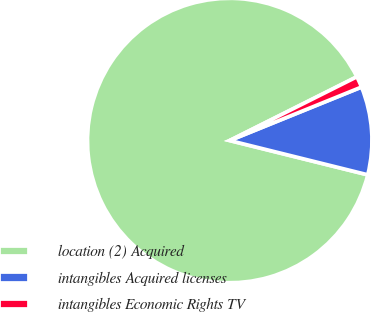Convert chart. <chart><loc_0><loc_0><loc_500><loc_500><pie_chart><fcel>location (2) Acquired<fcel>intangibles Acquired licenses<fcel>intangibles Economic Rights TV<nl><fcel>88.73%<fcel>10.01%<fcel>1.26%<nl></chart> 